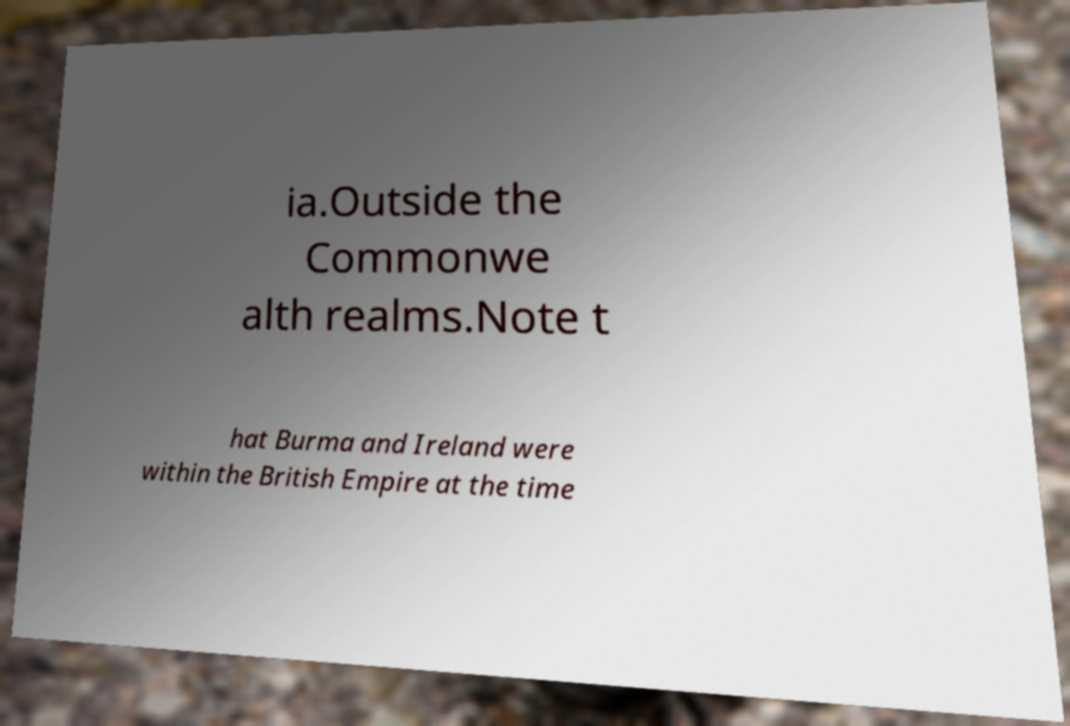Can you read and provide the text displayed in the image?This photo seems to have some interesting text. Can you extract and type it out for me? ia.Outside the Commonwe alth realms.Note t hat Burma and Ireland were within the British Empire at the time 